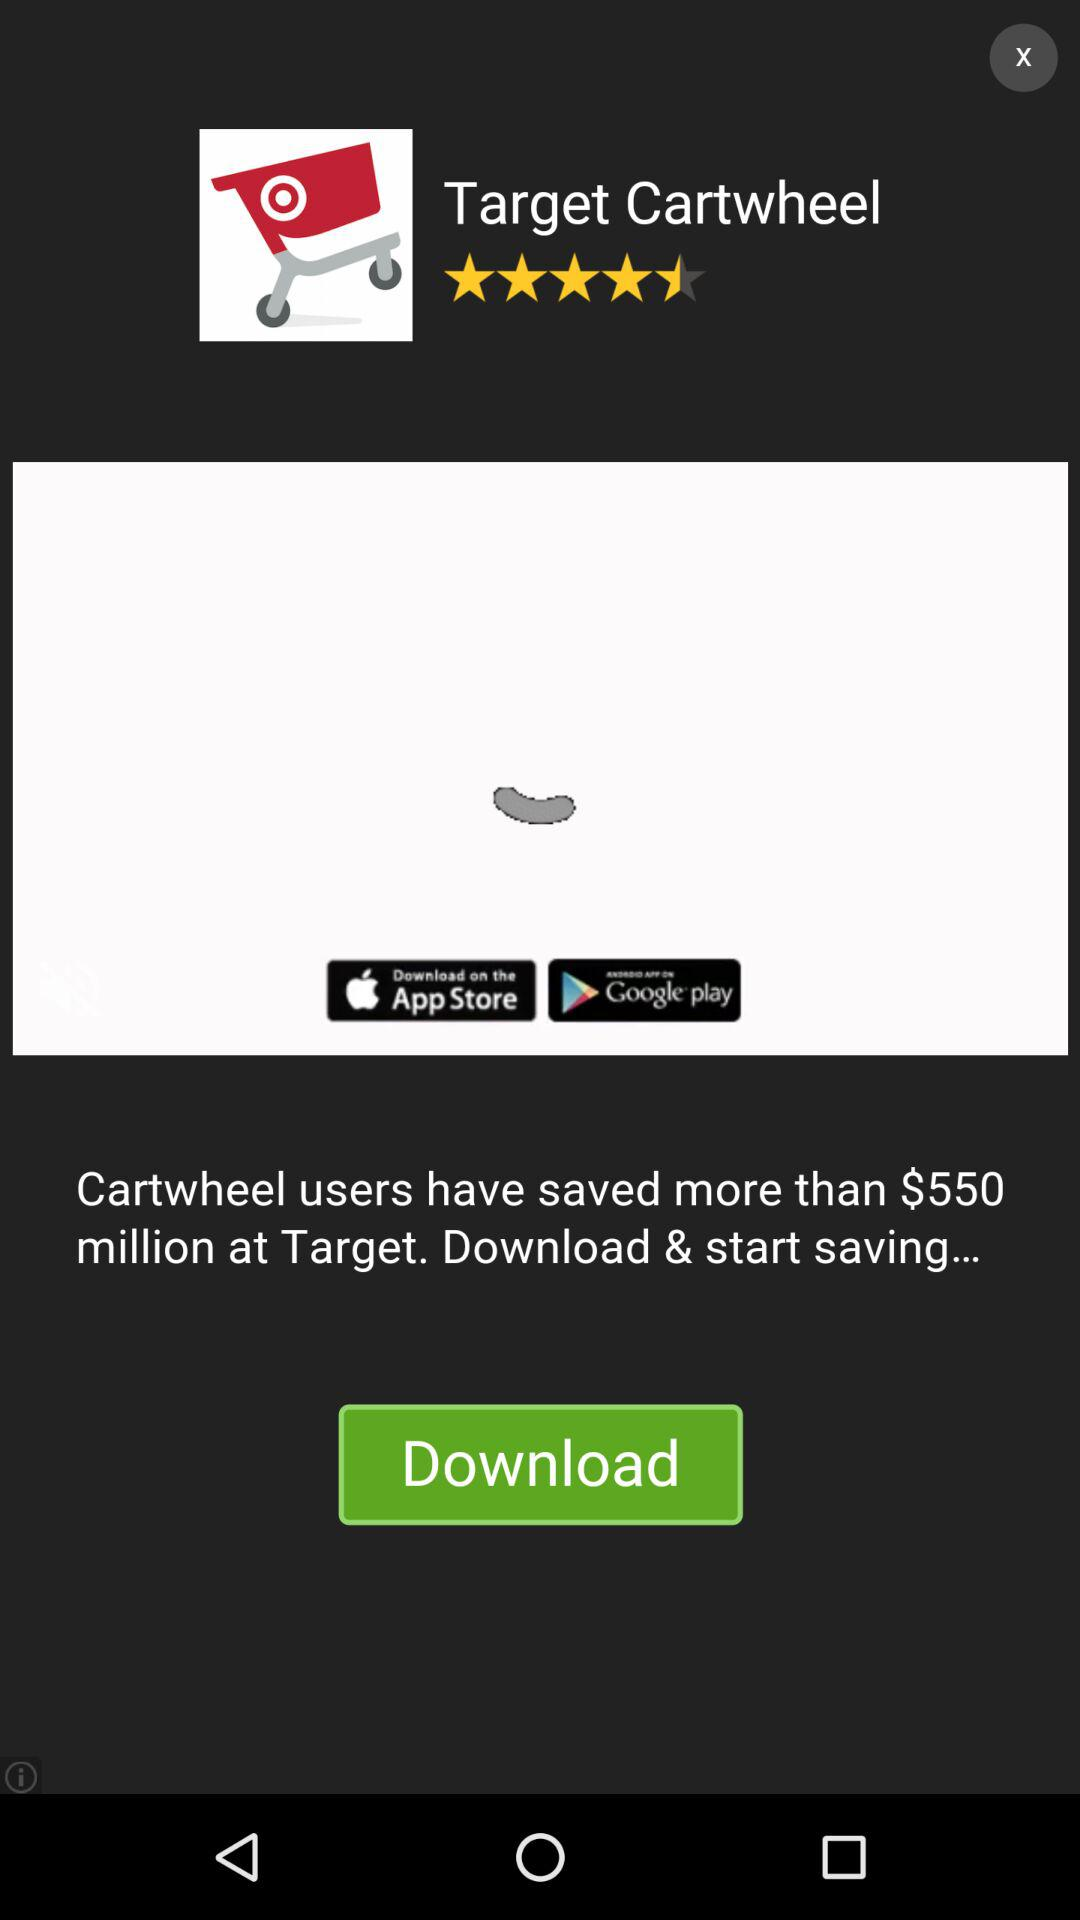How many download options are there for the Target Cartwheel app?
Answer the question using a single word or phrase. 2 